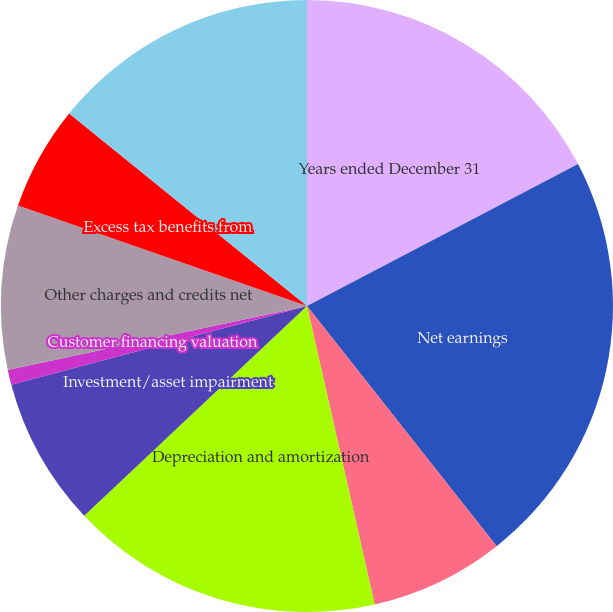Convert chart. <chart><loc_0><loc_0><loc_500><loc_500><pie_chart><fcel>Years ended December 31<fcel>Net earnings<fcel>Share-based plans expense<fcel>Depreciation and amortization<fcel>Investment/asset impairment<fcel>Customer financing valuation<fcel>Loss/(gain) on dispositions<fcel>Other charges and credits net<fcel>Excess tax benefits from<fcel>Accounts receivable<nl><fcel>17.32%<fcel>22.04%<fcel>7.09%<fcel>16.53%<fcel>7.88%<fcel>0.79%<fcel>0.01%<fcel>8.66%<fcel>5.51%<fcel>14.17%<nl></chart> 